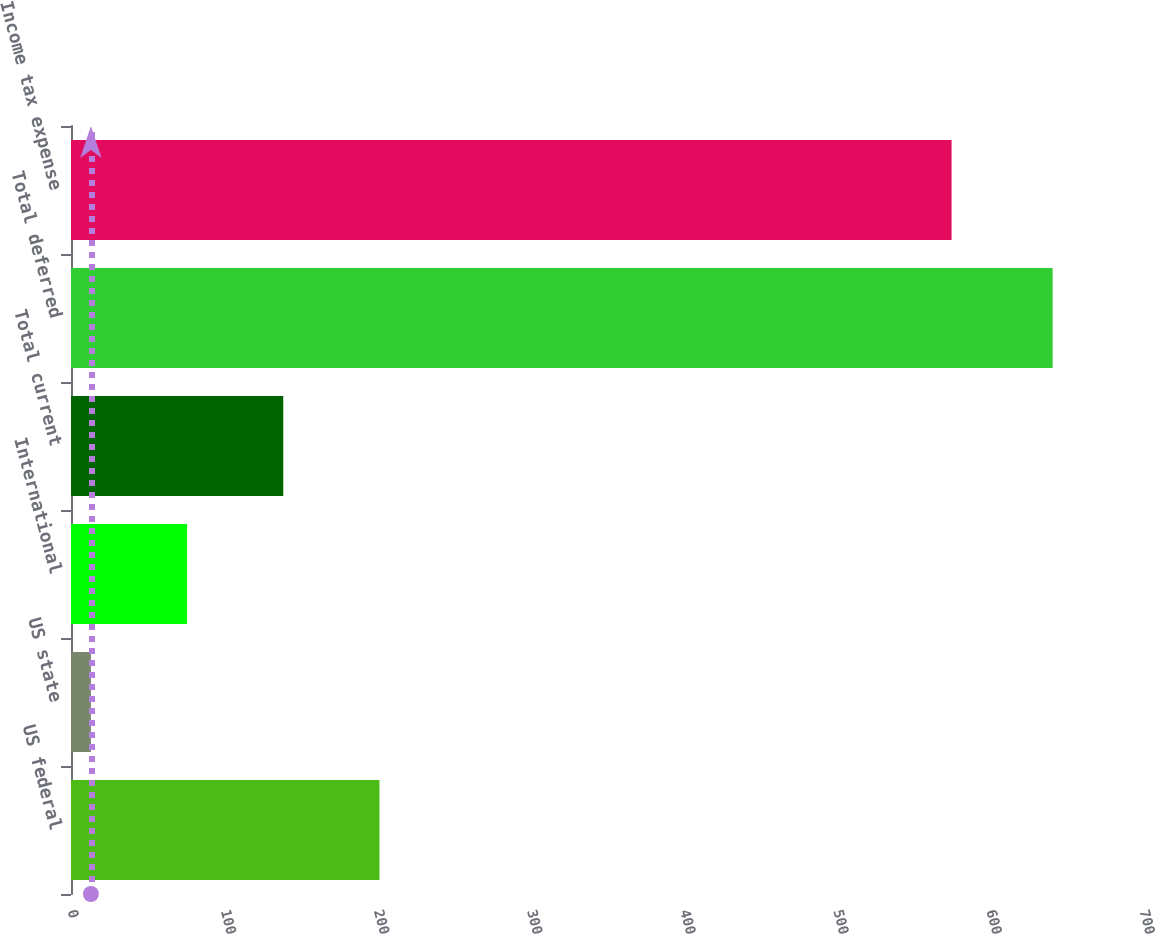<chart> <loc_0><loc_0><loc_500><loc_500><bar_chart><fcel>US federal<fcel>US state<fcel>International<fcel>Total current<fcel>Total deferred<fcel>Income tax expense<nl><fcel>201.4<fcel>13<fcel>75.8<fcel>138.6<fcel>641<fcel>575<nl></chart> 